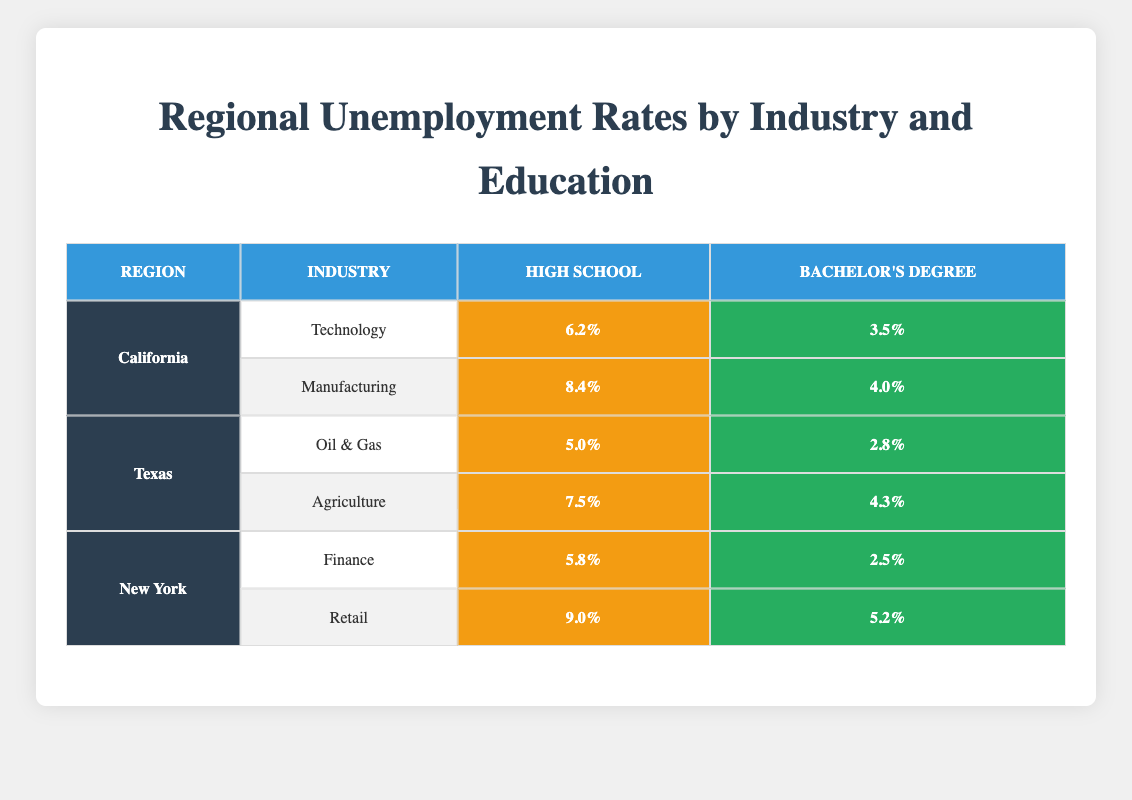What is the unemployment rate for high school graduates in California's manufacturing industry? The table lists the unemployment rates for different educational levels within California's manufacturing industry. For high school graduates, the unemployment rate is directly given as 8.4%.
Answer: 8.4% Which industry in Texas has the lowest unemployment rate for bachelor's degree holders? In the Texas section of the table, we see two industries listed: Oil & Gas and Agriculture. The unemployment rates for bachelor's degree holders are 2.8% and 4.3%, respectively. The lowest rate is 2.8% in the Oil & Gas industry.
Answer: 2.8% What is the average unemployment rate for bachelor's degree holders across all regions? The unemployment rates for bachelor's degree holders are 3.5% (California Technology), 4.0% (California Manufacturing), 2.8% (Texas Oil & Gas), 4.3% (Texas Agriculture), 2.5% (New York Finance), and 5.2% (New York Retail). There are 6 data points, and their total sum is 22.3%. Therefore, the average is 22.3% / 6 = 3.71667%, which rounds to approximately 3.72%.
Answer: 3.72% Is the unemployment rate for Agriculture in Texas higher than for Technology in California? The unemployment rate for Texas Agriculture (7.5%) is compared to that of California Technology (6.2%). Since 7.5% is greater than 6.2%, the statement is true.
Answer: Yes Which region has the highest unemployment rate for high school graduates in retail? Upon examining the New York section of the table, the unemployment rate for high school graduates in the retail sector is 9.0%, which is the highest among the provided data since no other regions with retail data for high school graduates exceed this rate.
Answer: 9.0% What is the difference in unemployment rates between high school and bachelor’s degree holders in the Finance industry of New York? In New York, the unemployment rate for high school graduates in Finance is 5.8%, and for bachelor's degree holders, it is 2.5%. The difference is calculated by subtracting the bachelor's rate from the high school rate: 5.8% - 2.5% = 3.3%.
Answer: 3.3% 